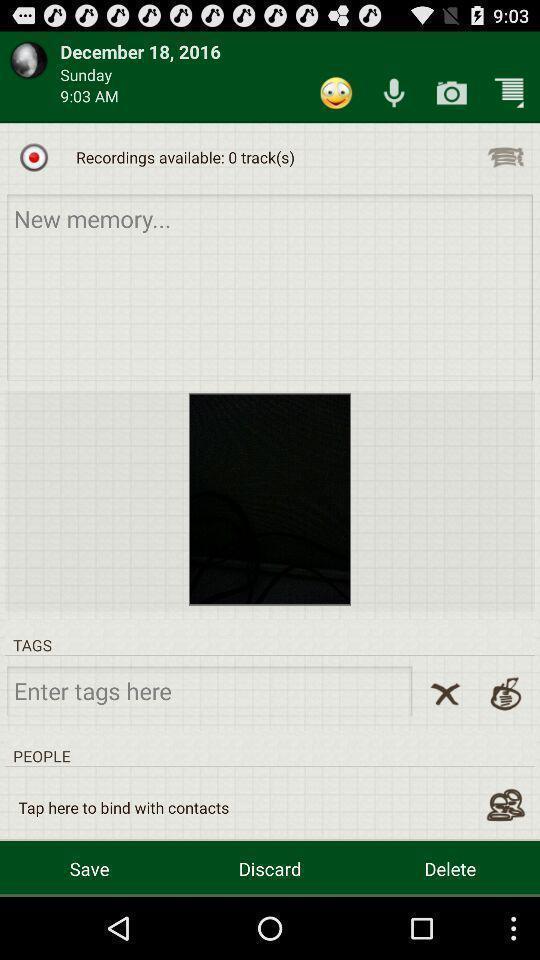Provide a description of this screenshot. Page displaying task of a date includes various options. 